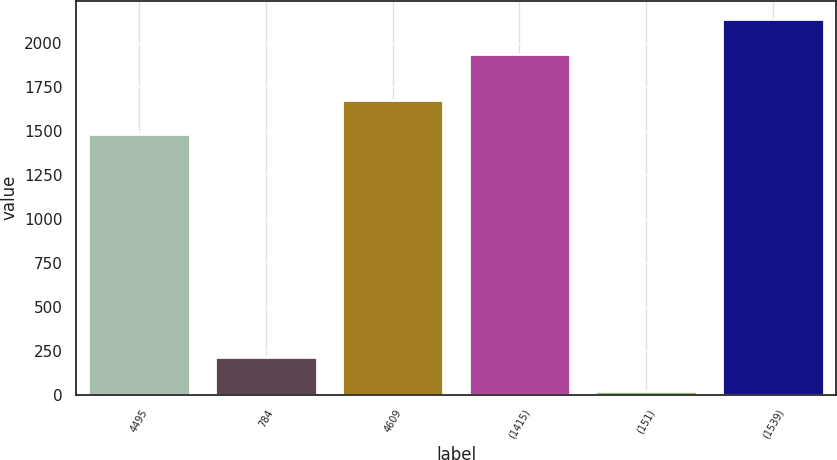Convert chart to OTSL. <chart><loc_0><loc_0><loc_500><loc_500><bar_chart><fcel>4495<fcel>784<fcel>4609<fcel>(1415)<fcel>(151)<fcel>(1539)<nl><fcel>1483<fcel>216.2<fcel>1677.2<fcel>1942<fcel>22<fcel>2136.2<nl></chart> 